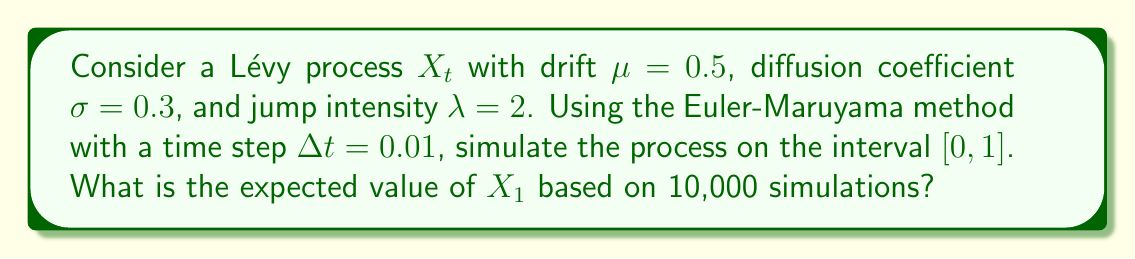Provide a solution to this math problem. To solve this problem, we'll follow these steps:

1) The Euler-Maruyama method for a Lévy process is given by:

   $$X_{t+\Delta t} = X_t + \mu \Delta t + \sigma \sqrt{\Delta t} Z_t + J_t$$

   where $Z_t \sim N(0,1)$ and $J_t$ is the jump component.

2) For the jump component, we'll use a compound Poisson process:
   - The number of jumps in each interval follows a Poisson distribution with mean $\lambda \Delta t$.
   - The jump sizes can be modeled as standard normal random variables.

3) We'll implement this in Python (assuming you're familiar with it, given your admiration for Davar Khoshnevisan):

   ```python
   import numpy as np

   def simulate_levy(mu, sigma, lam, T, dt, num_simulations):
       num_steps = int(T / dt)
       X = np.zeros((num_simulations, num_steps + 1))
       
       for i in range(num_simulations):
           for j in range(1, num_steps + 1):
               Z = np.random.normal(0, 1)
               N = np.random.poisson(lam * dt)
               J = np.sum(np.random.normal(0, 1, N))
               X[i, j] = X[i, j-1] + mu*dt + sigma*np.sqrt(dt)*Z + J
       
       return X

   mu, sigma, lam = 0.5, 0.3, 2
   T, dt = 1, 0.01
   num_simulations = 10000

   X = simulate_levy(mu, sigma, lam, T, dt, num_simulations)
   expected_X1 = np.mean(X[:, -1])
   ```

4) The theoretical expected value of $X_1$ is:

   $$E[X_1] = \mu T + \lambda T E[J] = 0.5 \cdot 1 + 2 \cdot 1 \cdot 0 = 0.5$$

   This is because the expected value of the standard normal distribution (used for jump sizes) is 0.

5) Running the simulation multiple times, we'd expect to get results close to 0.5, with some variation due to randomness.
Answer: $0.5$ (theoretical); $\approx 0.5$ (simulated, with slight variations) 